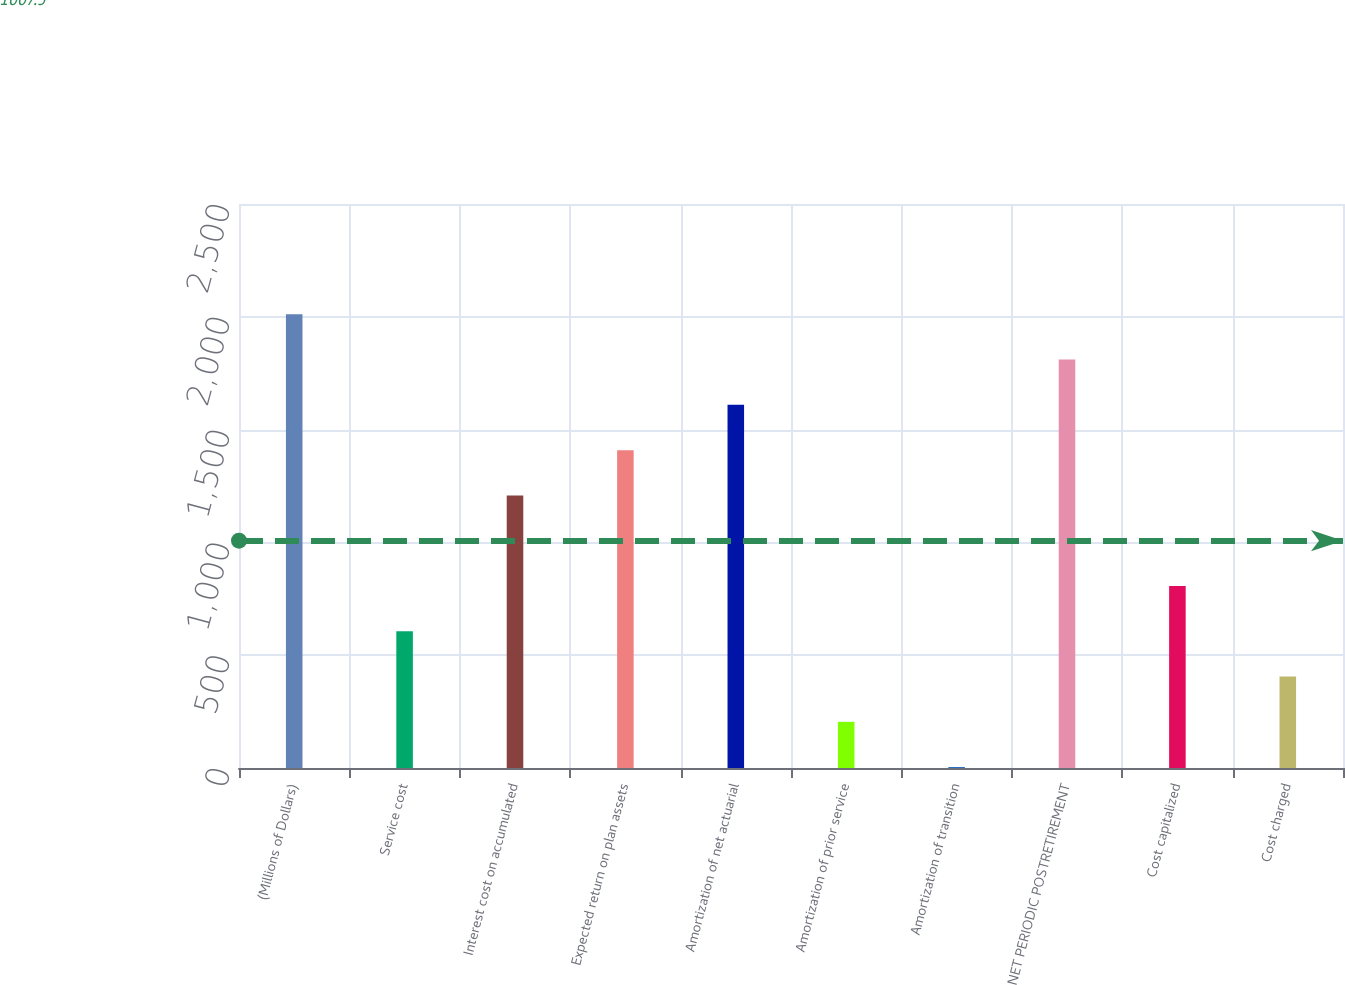Convert chart. <chart><loc_0><loc_0><loc_500><loc_500><bar_chart><fcel>(Millions of Dollars)<fcel>Service cost<fcel>Interest cost on accumulated<fcel>Expected return on plan assets<fcel>Amortization of net actuarial<fcel>Amortization of prior service<fcel>Amortization of transition<fcel>NET PERIODIC POSTRETIREMENT<fcel>Cost capitalized<fcel>Cost charged<nl><fcel>2011<fcel>606.1<fcel>1208.2<fcel>1408.9<fcel>1609.6<fcel>204.7<fcel>4<fcel>1810.3<fcel>806.8<fcel>405.4<nl></chart> 